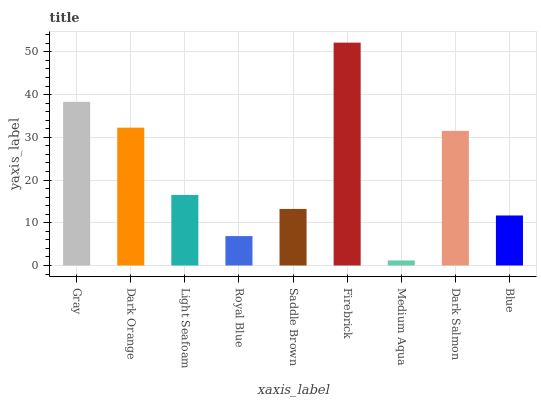Is Medium Aqua the minimum?
Answer yes or no. Yes. Is Firebrick the maximum?
Answer yes or no. Yes. Is Dark Orange the minimum?
Answer yes or no. No. Is Dark Orange the maximum?
Answer yes or no. No. Is Gray greater than Dark Orange?
Answer yes or no. Yes. Is Dark Orange less than Gray?
Answer yes or no. Yes. Is Dark Orange greater than Gray?
Answer yes or no. No. Is Gray less than Dark Orange?
Answer yes or no. No. Is Light Seafoam the high median?
Answer yes or no. Yes. Is Light Seafoam the low median?
Answer yes or no. Yes. Is Blue the high median?
Answer yes or no. No. Is Gray the low median?
Answer yes or no. No. 